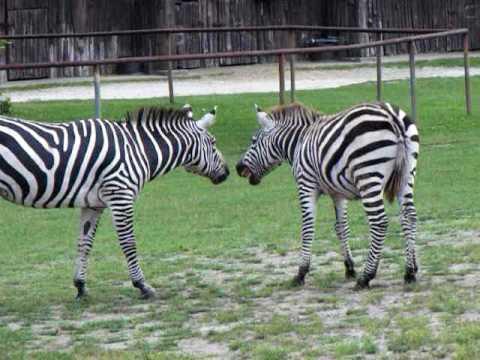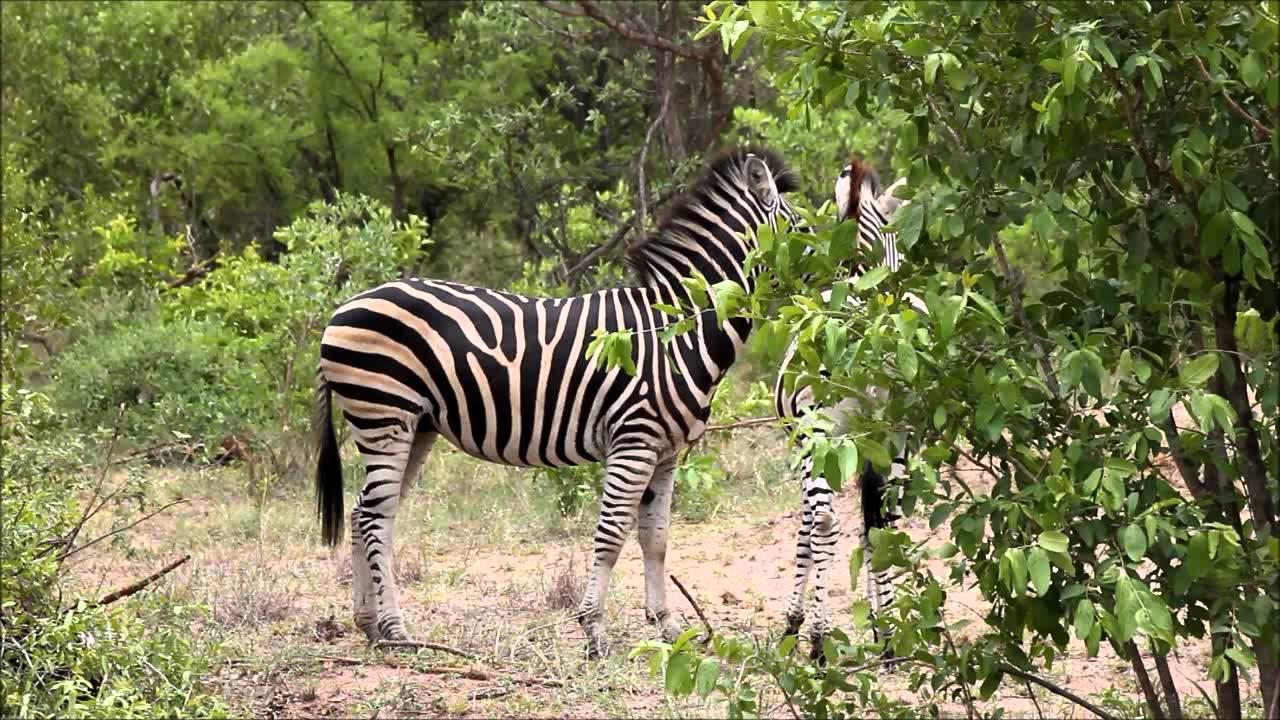The first image is the image on the left, the second image is the image on the right. Considering the images on both sides, is "One of the animals in the image on the right only has two feet on the ground." valid? Answer yes or no. No. The first image is the image on the left, the second image is the image on the right. Given the left and right images, does the statement "The left image shows a young zebra bounding leftward, with multiple feet off the ground, and the right image features two zebras fact-to-face." hold true? Answer yes or no. No. 